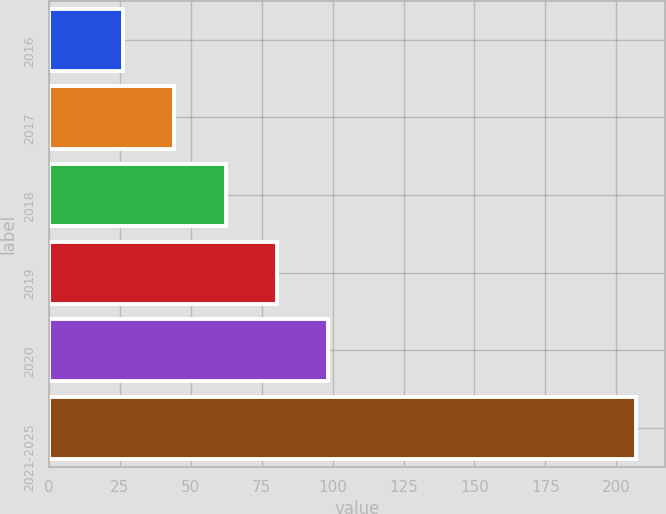Convert chart. <chart><loc_0><loc_0><loc_500><loc_500><bar_chart><fcel>2016<fcel>2017<fcel>2018<fcel>2019<fcel>2020<fcel>2021-2025<nl><fcel>26.1<fcel>44.18<fcel>62.26<fcel>80.34<fcel>98.42<fcel>206.9<nl></chart> 